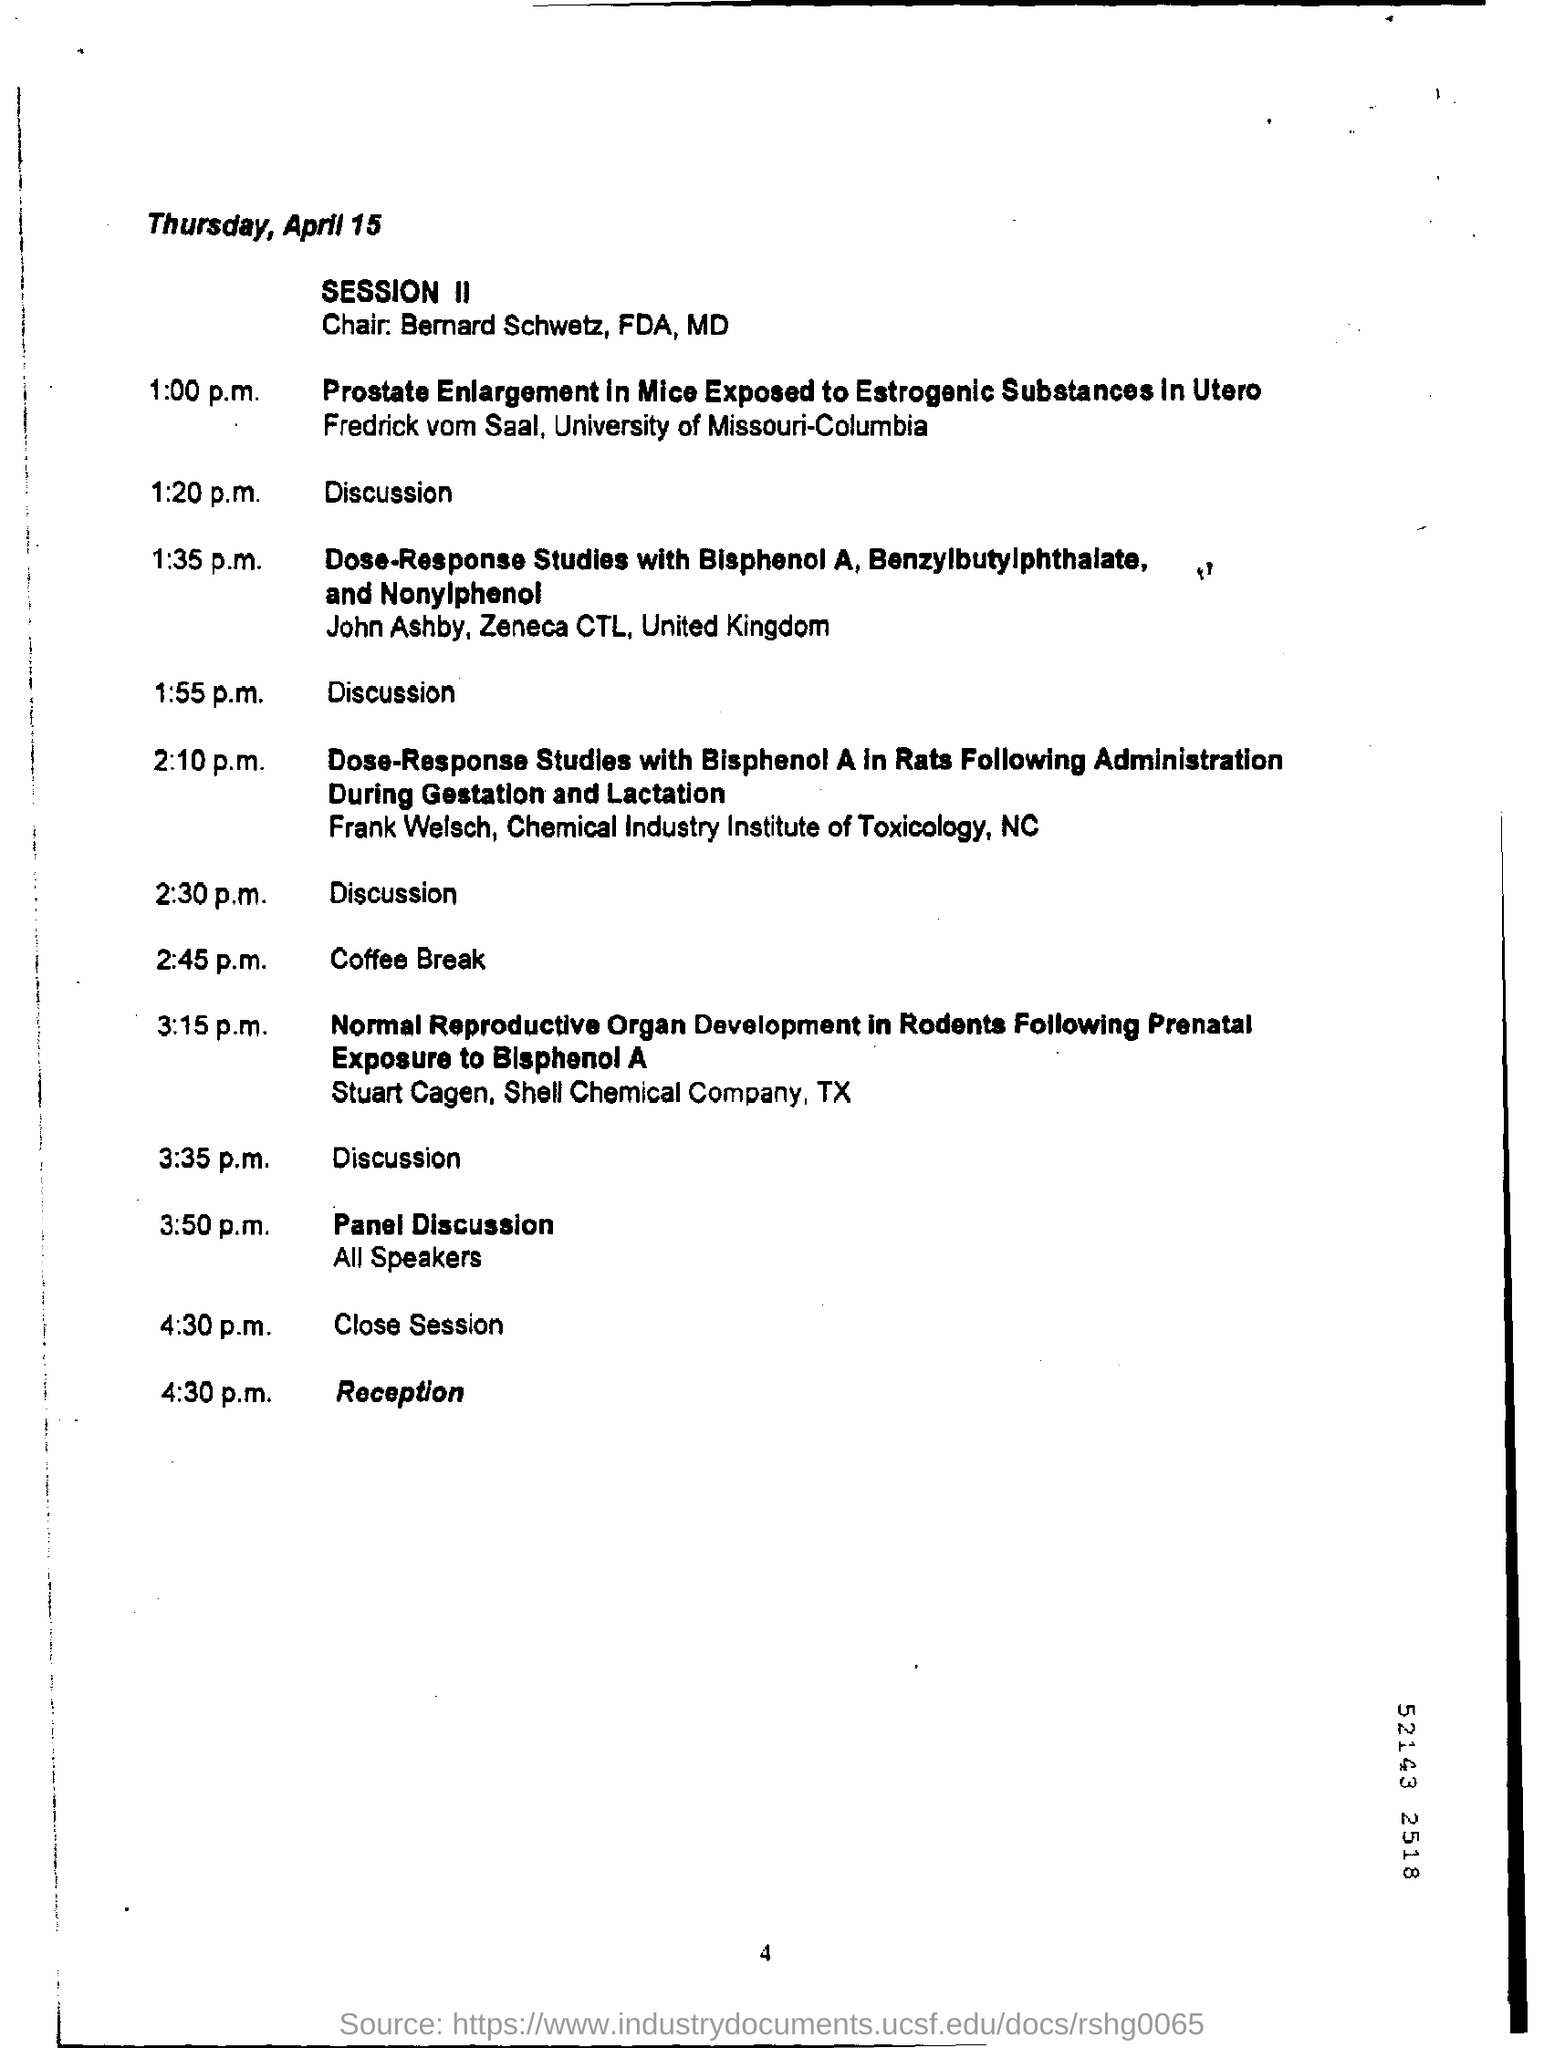Mention a couple of crucial points in this snapshot. April 15th is Thursday. 